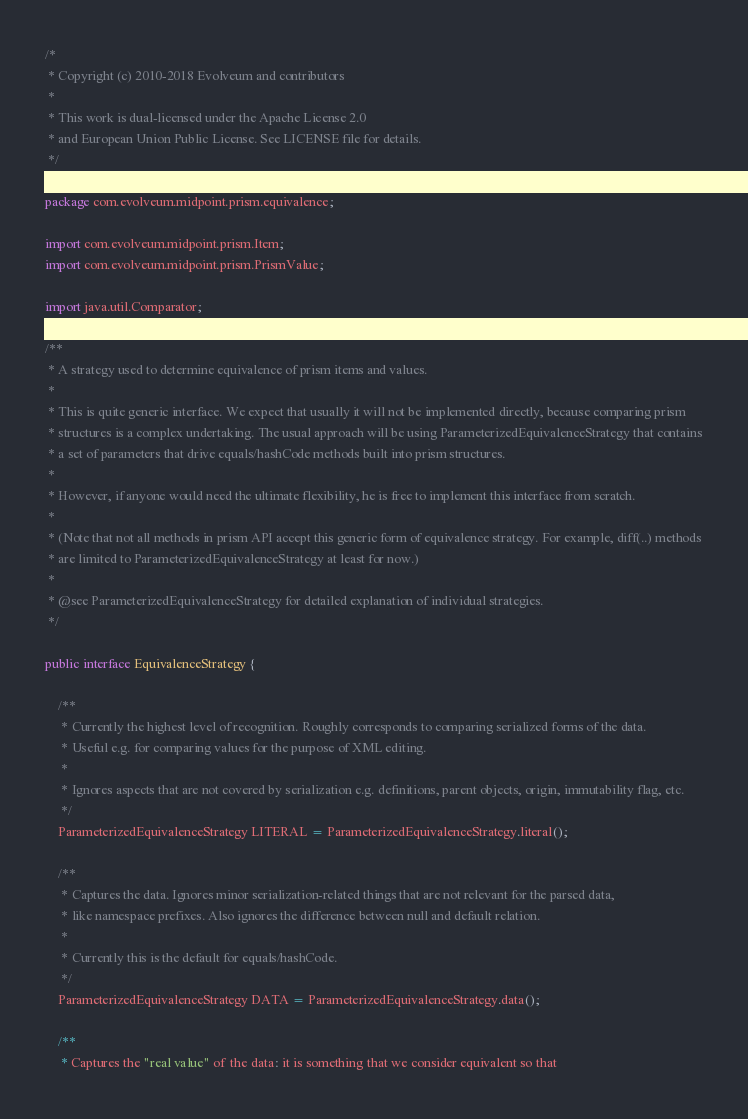Convert code to text. <code><loc_0><loc_0><loc_500><loc_500><_Java_>/*
 * Copyright (c) 2010-2018 Evolveum and contributors
 *
 * This work is dual-licensed under the Apache License 2.0
 * and European Union Public License. See LICENSE file for details.
 */

package com.evolveum.midpoint.prism.equivalence;

import com.evolveum.midpoint.prism.Item;
import com.evolveum.midpoint.prism.PrismValue;

import java.util.Comparator;

/**
 * A strategy used to determine equivalence of prism items and values.
 *
 * This is quite generic interface. We expect that usually it will not be implemented directly, because comparing prism
 * structures is a complex undertaking. The usual approach will be using ParameterizedEquivalenceStrategy that contains
 * a set of parameters that drive equals/hashCode methods built into prism structures.
 *
 * However, if anyone would need the ultimate flexibility, he is free to implement this interface from scratch.
 *
 * (Note that not all methods in prism API accept this generic form of equivalence strategy. For example, diff(..) methods
 * are limited to ParameterizedEquivalenceStrategy at least for now.)
 *
 * @see ParameterizedEquivalenceStrategy for detailed explanation of individual strategies.
 */

public interface EquivalenceStrategy {

    /**
     * Currently the highest level of recognition. Roughly corresponds to comparing serialized forms of the data.
     * Useful e.g. for comparing values for the purpose of XML editing.
     *
     * Ignores aspects that are not covered by serialization e.g. definitions, parent objects, origin, immutability flag, etc.
     */
    ParameterizedEquivalenceStrategy LITERAL = ParameterizedEquivalenceStrategy.literal();

    /**
     * Captures the data. Ignores minor serialization-related things that are not relevant for the parsed data,
     * like namespace prefixes. Also ignores the difference between null and default relation.
     *
     * Currently this is the default for equals/hashCode.
     */
    ParameterizedEquivalenceStrategy DATA = ParameterizedEquivalenceStrategy.data();

    /**
     * Captures the "real value" of the data: it is something that we consider equivalent so that</code> 